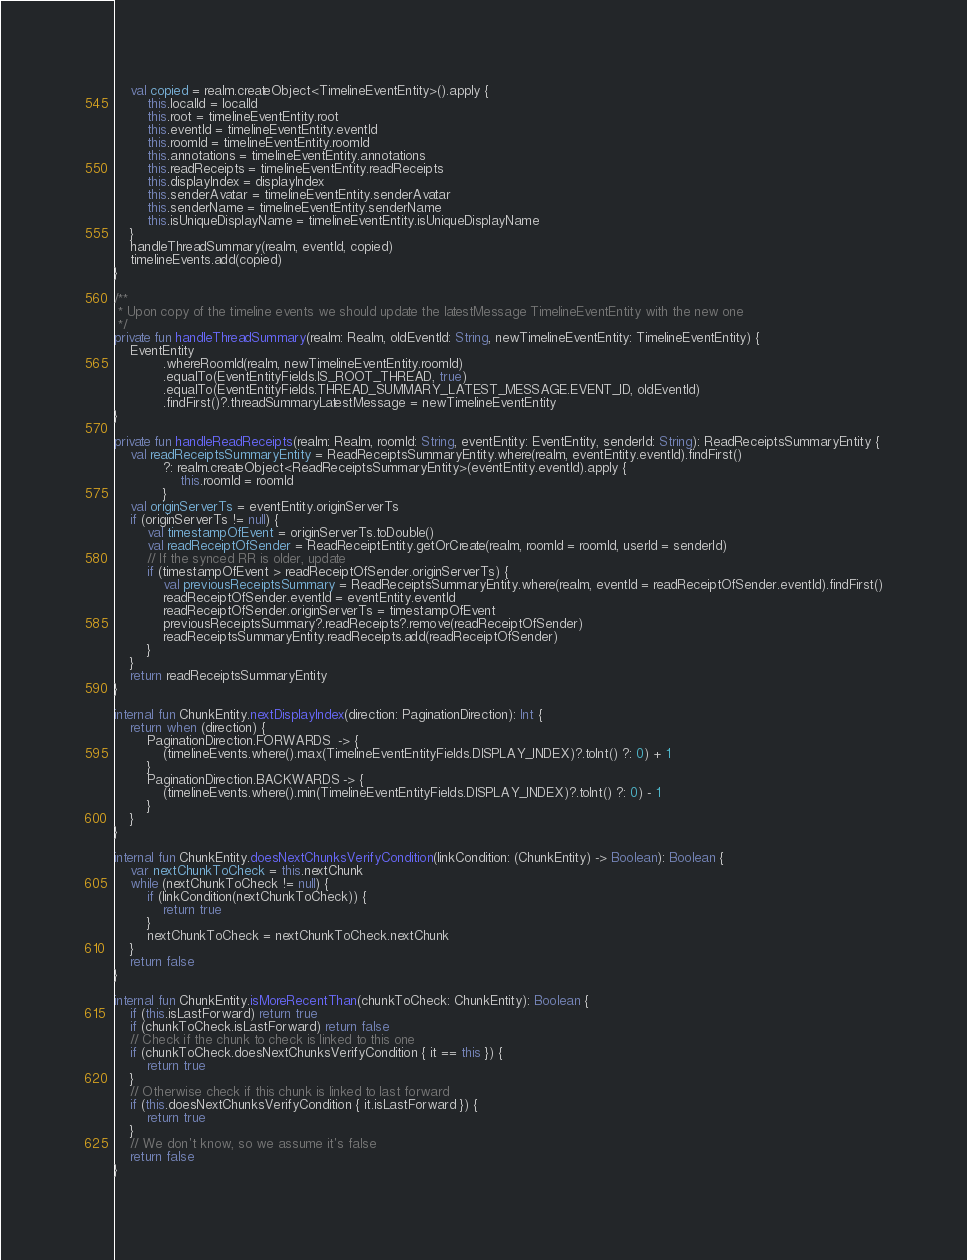Convert code to text. <code><loc_0><loc_0><loc_500><loc_500><_Kotlin_>    val copied = realm.createObject<TimelineEventEntity>().apply {
        this.localId = localId
        this.root = timelineEventEntity.root
        this.eventId = timelineEventEntity.eventId
        this.roomId = timelineEventEntity.roomId
        this.annotations = timelineEventEntity.annotations
        this.readReceipts = timelineEventEntity.readReceipts
        this.displayIndex = displayIndex
        this.senderAvatar = timelineEventEntity.senderAvatar
        this.senderName = timelineEventEntity.senderName
        this.isUniqueDisplayName = timelineEventEntity.isUniqueDisplayName
    }
    handleThreadSummary(realm, eventId, copied)
    timelineEvents.add(copied)
}

/**
 * Upon copy of the timeline events we should update the latestMessage TimelineEventEntity with the new one
 */
private fun handleThreadSummary(realm: Realm, oldEventId: String, newTimelineEventEntity: TimelineEventEntity) {
    EventEntity
            .whereRoomId(realm, newTimelineEventEntity.roomId)
            .equalTo(EventEntityFields.IS_ROOT_THREAD, true)
            .equalTo(EventEntityFields.THREAD_SUMMARY_LATEST_MESSAGE.EVENT_ID, oldEventId)
            .findFirst()?.threadSummaryLatestMessage = newTimelineEventEntity
}

private fun handleReadReceipts(realm: Realm, roomId: String, eventEntity: EventEntity, senderId: String): ReadReceiptsSummaryEntity {
    val readReceiptsSummaryEntity = ReadReceiptsSummaryEntity.where(realm, eventEntity.eventId).findFirst()
            ?: realm.createObject<ReadReceiptsSummaryEntity>(eventEntity.eventId).apply {
                this.roomId = roomId
            }
    val originServerTs = eventEntity.originServerTs
    if (originServerTs != null) {
        val timestampOfEvent = originServerTs.toDouble()
        val readReceiptOfSender = ReadReceiptEntity.getOrCreate(realm, roomId = roomId, userId = senderId)
        // If the synced RR is older, update
        if (timestampOfEvent > readReceiptOfSender.originServerTs) {
            val previousReceiptsSummary = ReadReceiptsSummaryEntity.where(realm, eventId = readReceiptOfSender.eventId).findFirst()
            readReceiptOfSender.eventId = eventEntity.eventId
            readReceiptOfSender.originServerTs = timestampOfEvent
            previousReceiptsSummary?.readReceipts?.remove(readReceiptOfSender)
            readReceiptsSummaryEntity.readReceipts.add(readReceiptOfSender)
        }
    }
    return readReceiptsSummaryEntity
}

internal fun ChunkEntity.nextDisplayIndex(direction: PaginationDirection): Int {
    return when (direction) {
        PaginationDirection.FORWARDS  -> {
            (timelineEvents.where().max(TimelineEventEntityFields.DISPLAY_INDEX)?.toInt() ?: 0) + 1
        }
        PaginationDirection.BACKWARDS -> {
            (timelineEvents.where().min(TimelineEventEntityFields.DISPLAY_INDEX)?.toInt() ?: 0) - 1
        }
    }
}

internal fun ChunkEntity.doesNextChunksVerifyCondition(linkCondition: (ChunkEntity) -> Boolean): Boolean {
    var nextChunkToCheck = this.nextChunk
    while (nextChunkToCheck != null) {
        if (linkCondition(nextChunkToCheck)) {
            return true
        }
        nextChunkToCheck = nextChunkToCheck.nextChunk
    }
    return false
}

internal fun ChunkEntity.isMoreRecentThan(chunkToCheck: ChunkEntity): Boolean {
    if (this.isLastForward) return true
    if (chunkToCheck.isLastForward) return false
    // Check if the chunk to check is linked to this one
    if (chunkToCheck.doesNextChunksVerifyCondition { it == this }) {
        return true
    }
    // Otherwise check if this chunk is linked to last forward
    if (this.doesNextChunksVerifyCondition { it.isLastForward }) {
        return true
    }
    // We don't know, so we assume it's false
    return false
}
</code> 